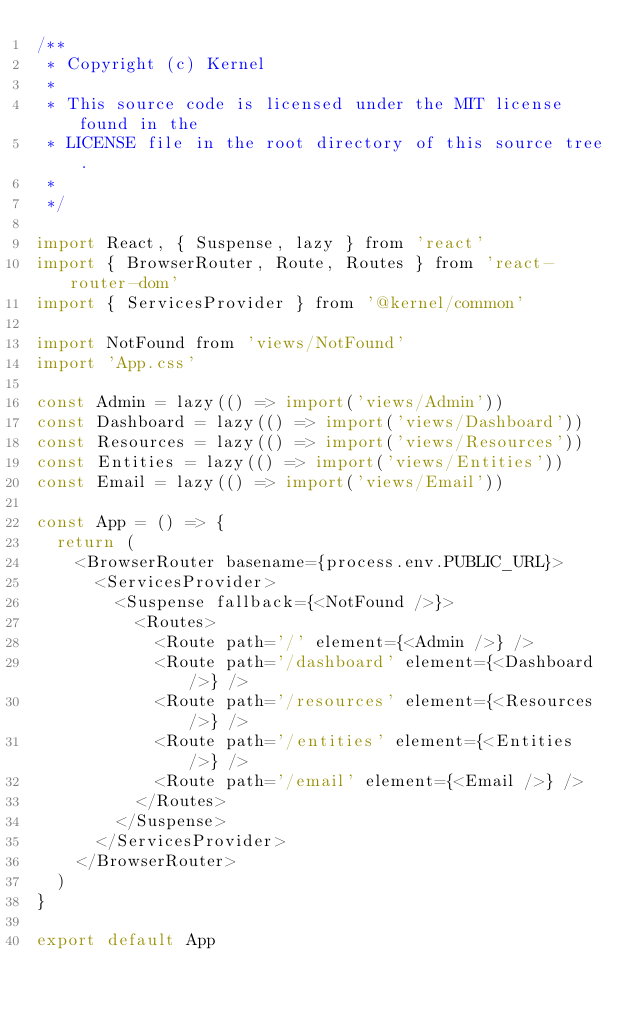<code> <loc_0><loc_0><loc_500><loc_500><_JavaScript_>/**
 * Copyright (c) Kernel
 *
 * This source code is licensed under the MIT license found in the
 * LICENSE file in the root directory of this source tree.
 *
 */

import React, { Suspense, lazy } from 'react'
import { BrowserRouter, Route, Routes } from 'react-router-dom'
import { ServicesProvider } from '@kernel/common'

import NotFound from 'views/NotFound'
import 'App.css'

const Admin = lazy(() => import('views/Admin'))
const Dashboard = lazy(() => import('views/Dashboard'))
const Resources = lazy(() => import('views/Resources'))
const Entities = lazy(() => import('views/Entities'))
const Email = lazy(() => import('views/Email'))

const App = () => {
  return (
    <BrowserRouter basename={process.env.PUBLIC_URL}>
      <ServicesProvider>
        <Suspense fallback={<NotFound />}>
          <Routes>
            <Route path='/' element={<Admin />} />
            <Route path='/dashboard' element={<Dashboard />} />
            <Route path='/resources' element={<Resources />} />
            <Route path='/entities' element={<Entities />} />
            <Route path='/email' element={<Email />} />
          </Routes>
        </Suspense>
      </ServicesProvider>
    </BrowserRouter>
  )
}

export default App
</code> 